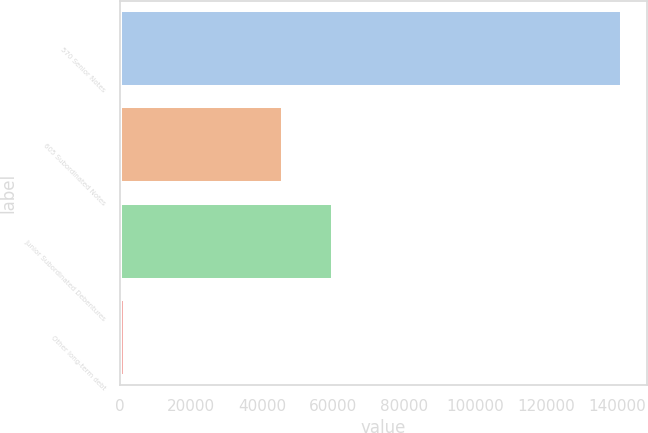<chart> <loc_0><loc_0><loc_500><loc_500><bar_chart><fcel>570 Senior Notes<fcel>605 Subordinated Notes<fcel>Junior Subordinated Debentures<fcel>Other long-term debt<nl><fcel>141429<fcel>45964<fcel>59963<fcel>1439<nl></chart> 